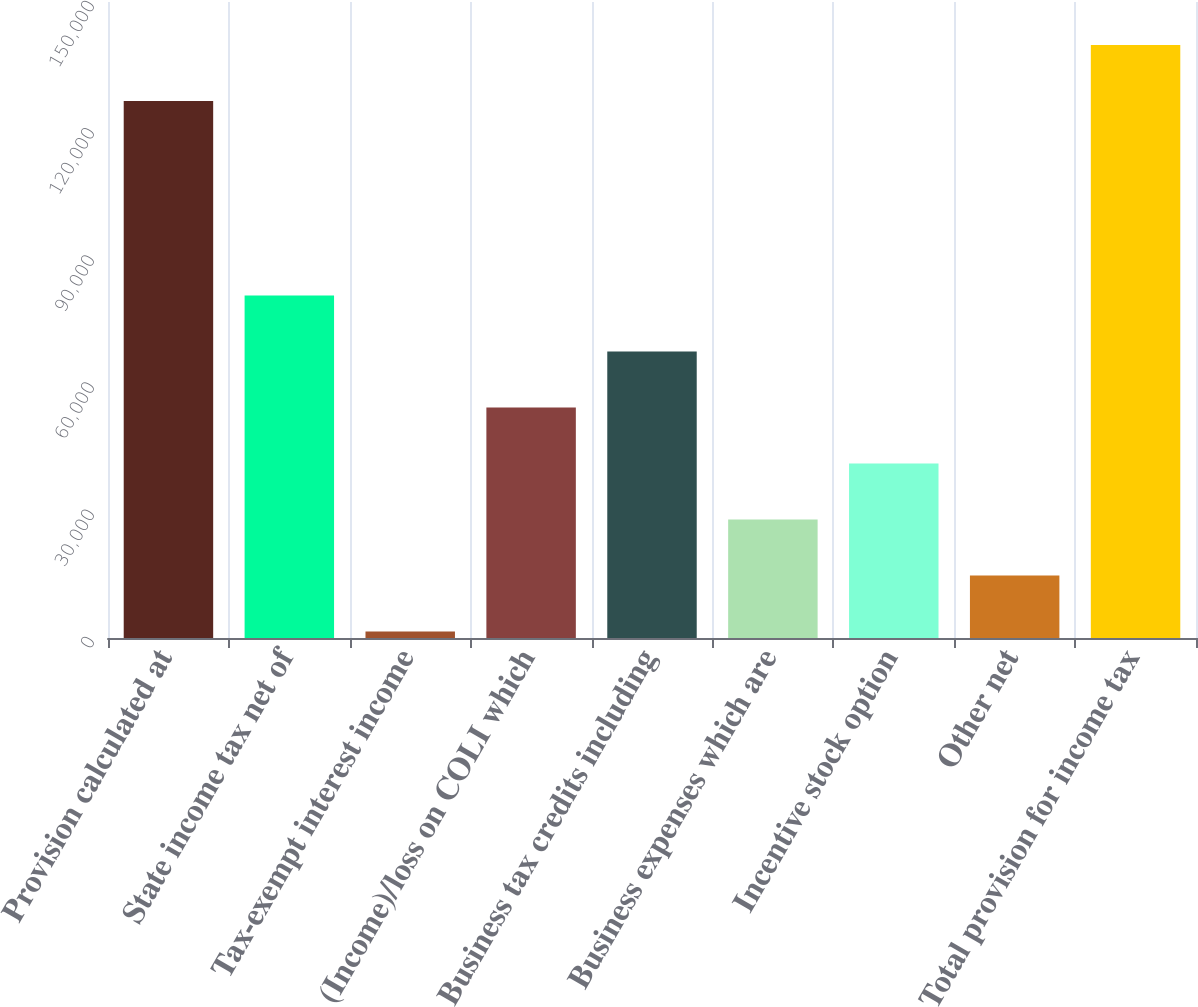Convert chart to OTSL. <chart><loc_0><loc_0><loc_500><loc_500><bar_chart><fcel>Provision calculated at<fcel>State income tax net of<fcel>Tax-exempt interest income<fcel>(Income)/loss on COLI which<fcel>Business tax credits including<fcel>Business expenses which are<fcel>Incentive stock option<fcel>Other net<fcel>Total provision for income tax<nl><fcel>126667<fcel>80794.6<fcel>1549<fcel>54379.4<fcel>67587<fcel>27964.2<fcel>41171.8<fcel>14756.6<fcel>139875<nl></chart> 